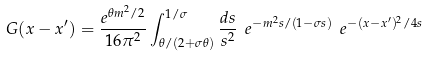Convert formula to latex. <formula><loc_0><loc_0><loc_500><loc_500>G ( x - x ^ { \prime } ) = \frac { e ^ { \theta m ^ { 2 } / 2 } } { 1 6 \pi ^ { 2 } } \int _ { \theta / ( 2 + \sigma \theta ) } ^ { 1 / \sigma } \frac { d s } { s ^ { 2 } } \ e ^ { - m ^ { 2 } s / ( 1 - \sigma s ) } \ e ^ { - ( x - x ^ { \prime } ) ^ { 2 } / 4 s }</formula> 